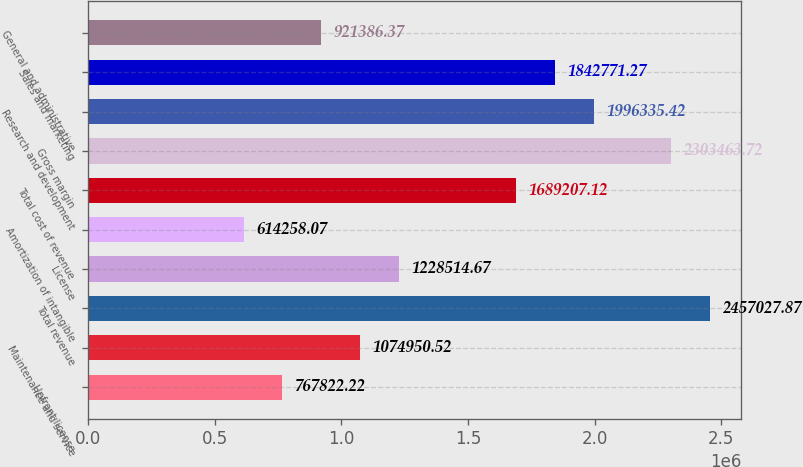<chart> <loc_0><loc_0><loc_500><loc_500><bar_chart><fcel>Upfront license<fcel>Maintenance and service<fcel>Total revenue<fcel>License<fcel>Amortization of intangible<fcel>Total cost of revenue<fcel>Gross margin<fcel>Research and development<fcel>Sales and marketing<fcel>General and administrative<nl><fcel>767822<fcel>1.07495e+06<fcel>2.45703e+06<fcel>1.22851e+06<fcel>614258<fcel>1.68921e+06<fcel>2.30346e+06<fcel>1.99634e+06<fcel>1.84277e+06<fcel>921386<nl></chart> 